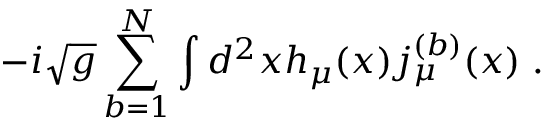<formula> <loc_0><loc_0><loc_500><loc_500>- i \sqrt { g } \sum _ { b = 1 } ^ { N } \int d ^ { 2 } x h _ { \mu } ( x ) j _ { \mu } ^ { ( b ) } ( x ) \, .</formula> 